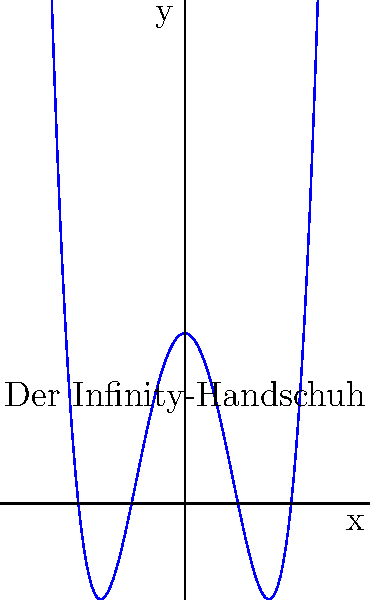Die Grafik zeigt eine Polynomfunktion, die die Form des Infinity-Handschuhs darstellt. Basierend auf der Grafik, was ist der Grad dieses Polynoms und wie viele reelle Nullstellen hat es? Geben Sie Ihre Antwort im Format "Grad, Anzahl der Nullstellen" an. Um diese Frage zu beantworten, müssen wir die Eigenschaften der Polynomfunktion analysieren:

1. Grad des Polynoms:
   - Der Grad eines Polynoms ist gleich der höchsten Potenz der Variablen.
   - In diesem Fall sehen wir, dass die Funktion 4 Mal die x-Achse schneidet oder berührt.
   - Ein Polynom vom Grad $n$ kann maximal $n$ reelle Nullstellen haben.
   - Da wir 4 Nullstellen sehen, muss der Grad des Polynoms mindestens 4 sein.
   - Die Form der Kurve deutet darauf hin, dass es sich um ein Polynom 4. Grades handelt, da es keine weiteren Wendepunkte gibt.

2. Anzahl der reellen Nullstellen:
   - Die reellen Nullstellen sind die Punkte, an denen das Polynom die x-Achse schneidet.
   - Aus der Grafik können wir 4 solcher Punkte identifizieren: bei x ≈ -4, -2, 2 und 4.

Daher ist der Grad des Polynoms 4, und es hat 4 reelle Nullstellen.
Answer: 4, 4 